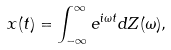Convert formula to latex. <formula><loc_0><loc_0><loc_500><loc_500>x ( t ) = \int _ { - \infty } ^ { \infty } e ^ { i \omega t } d Z ( \omega ) ,</formula> 